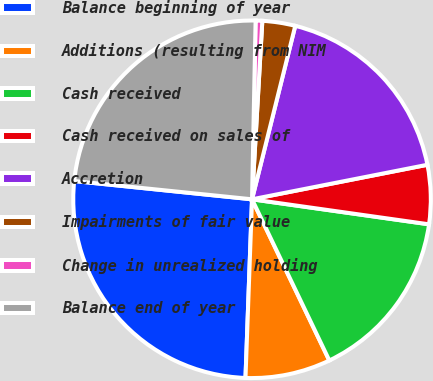Convert chart to OTSL. <chart><loc_0><loc_0><loc_500><loc_500><pie_chart><fcel>Balance beginning of year<fcel>Additions (resulting from NIM<fcel>Cash received<fcel>Cash received on sales of<fcel>Accretion<fcel>Impairments of fair value<fcel>Change in unrealized holding<fcel>Balance end of year<nl><fcel>26.05%<fcel>7.7%<fcel>15.65%<fcel>5.33%<fcel>18.02%<fcel>2.97%<fcel>0.6%<fcel>23.69%<nl></chart> 